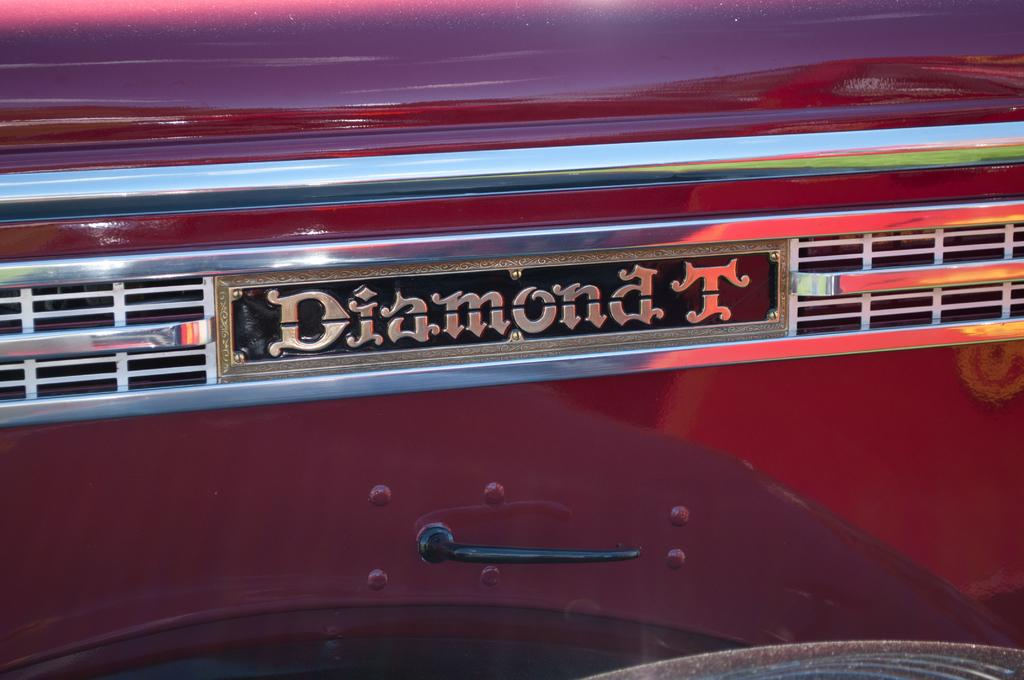What is the main subject in the image? There is a vehicle in the image. What else can be seen in the image besides the vehicle? There is writing on a black surface and a handle in the image. What type of waves can be seen in the image? There are no waves present in the image. 